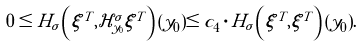<formula> <loc_0><loc_0><loc_500><loc_500>0 \leq H _ { \sigma } \left ( \xi ^ { T } , \mathcal { H } _ { y _ { 0 } } ^ { \sigma } \xi ^ { T } \right ) ( y _ { 0 } ) \leq c _ { 4 } \cdot H _ { \sigma } \left ( \xi ^ { T } , \xi ^ { T } \right ) ( y _ { 0 } ) .</formula> 